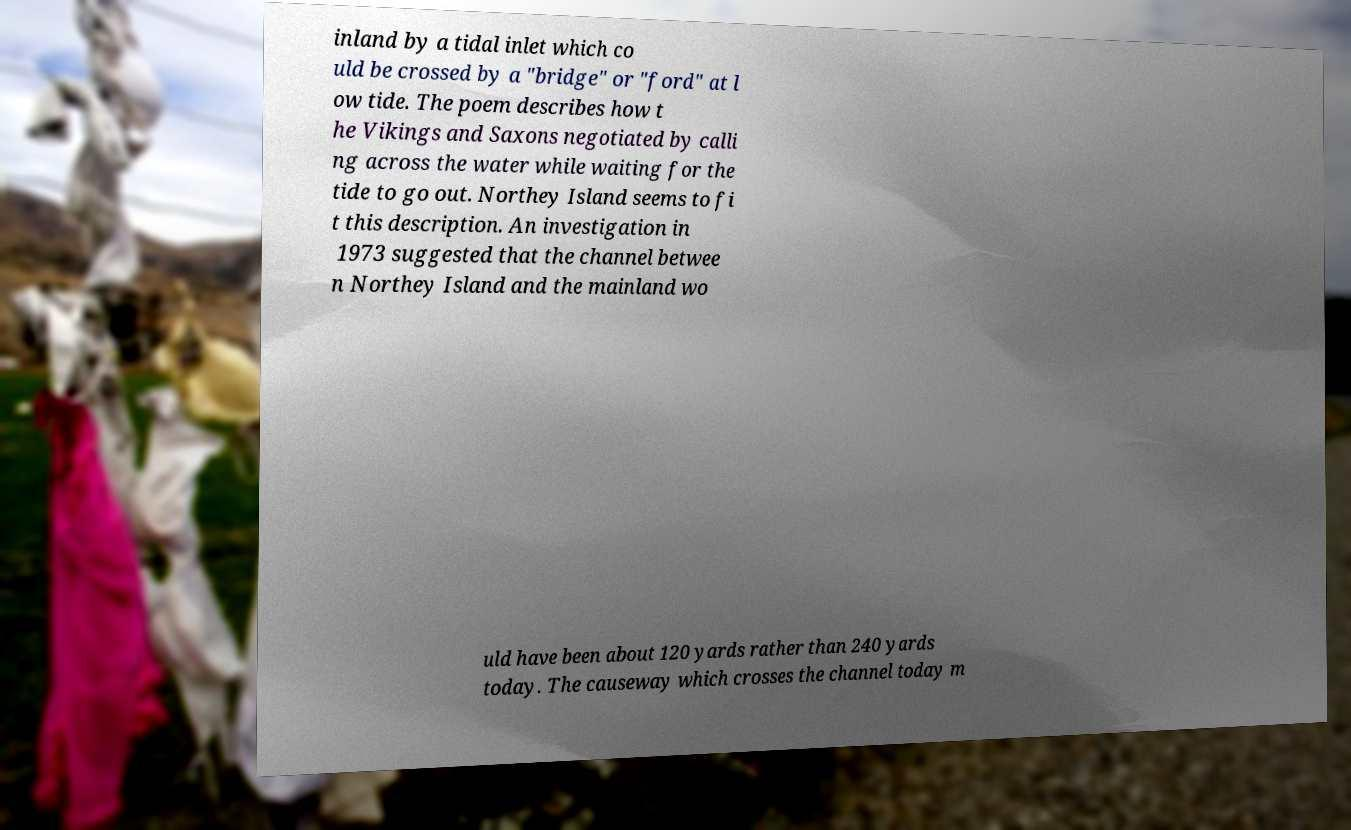Please identify and transcribe the text found in this image. inland by a tidal inlet which co uld be crossed by a "bridge" or "ford" at l ow tide. The poem describes how t he Vikings and Saxons negotiated by calli ng across the water while waiting for the tide to go out. Northey Island seems to fi t this description. An investigation in 1973 suggested that the channel betwee n Northey Island and the mainland wo uld have been about 120 yards rather than 240 yards today. The causeway which crosses the channel today m 